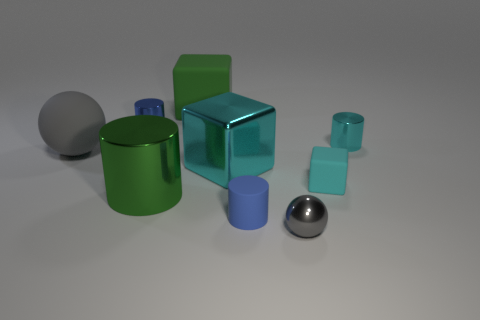Is the number of tiny metal spheres on the left side of the gray matte sphere the same as the number of big metallic blocks?
Your answer should be very brief. No. How many things are either tiny metal balls or small cylinders on the left side of the cyan cylinder?
Provide a succinct answer. 3. Is there a tiny brown object of the same shape as the gray metal object?
Your response must be concise. No. Are there the same number of rubber cylinders on the right side of the tiny shiny sphere and green metal cylinders behind the tiny cyan metal cylinder?
Provide a short and direct response. Yes. Is there any other thing that is the same size as the shiny ball?
Ensure brevity in your answer.  Yes. How many green objects are objects or large metallic cylinders?
Provide a succinct answer. 2. How many rubber blocks are the same size as the gray matte thing?
Provide a short and direct response. 1. There is a thing that is on the right side of the small metal sphere and in front of the large rubber sphere; what color is it?
Your response must be concise. Cyan. Are there more large matte balls that are to the left of the big green cylinder than large cyan cubes?
Provide a succinct answer. No. Are any gray metallic objects visible?
Offer a very short reply. Yes. 